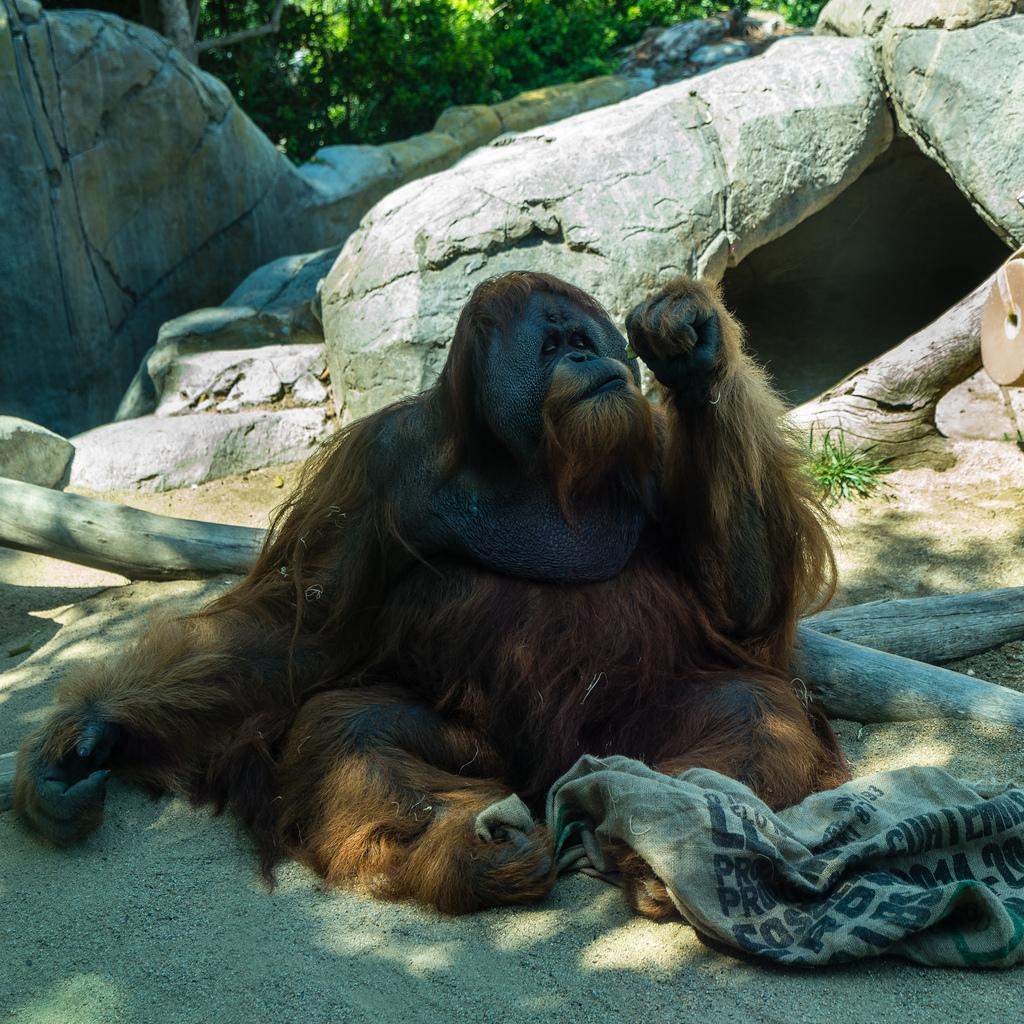What type of animal is on the ground in the image? The specific type of animal cannot be determined from the provided facts. What objects are present on the ground in the image? There are wooden logs visible in the image. What can be seen in the background of the image? There are rocks and trees or plants visible in the background of the image. What type of humor is being displayed by the star in the image? There is no star present in the image, and therefore no humor can be attributed to it. 